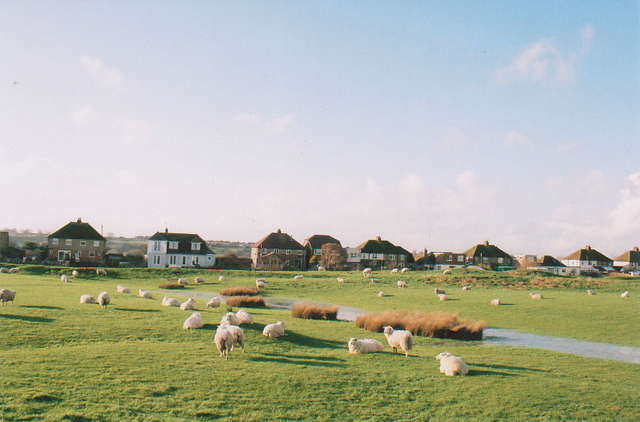<image>Have the sheep been recently sheared? It is unknown if the sheep have been recently sheared, but majority of the answers suggest 'no'. Have the sheep been recently sheared? I don't know if the sheep have been recently sheared. It can be both yes or no. 